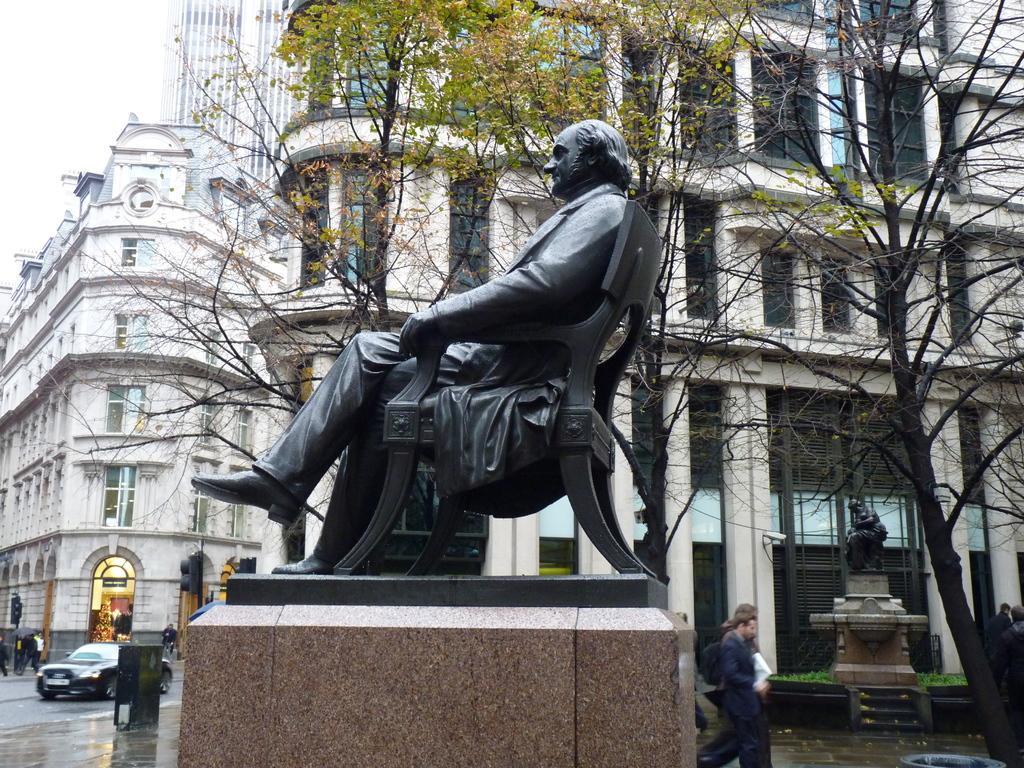Please provide a concise description of this image. In this image in the middle there is a statue of a man sitting on chair. In the background there are trees buildings. Here there is another statue. On the road many people are walking. Few vehicles are moving on the road. 